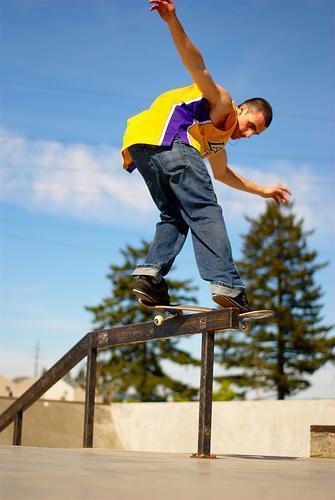How many people are in the photo?
Give a very brief answer. 1. 